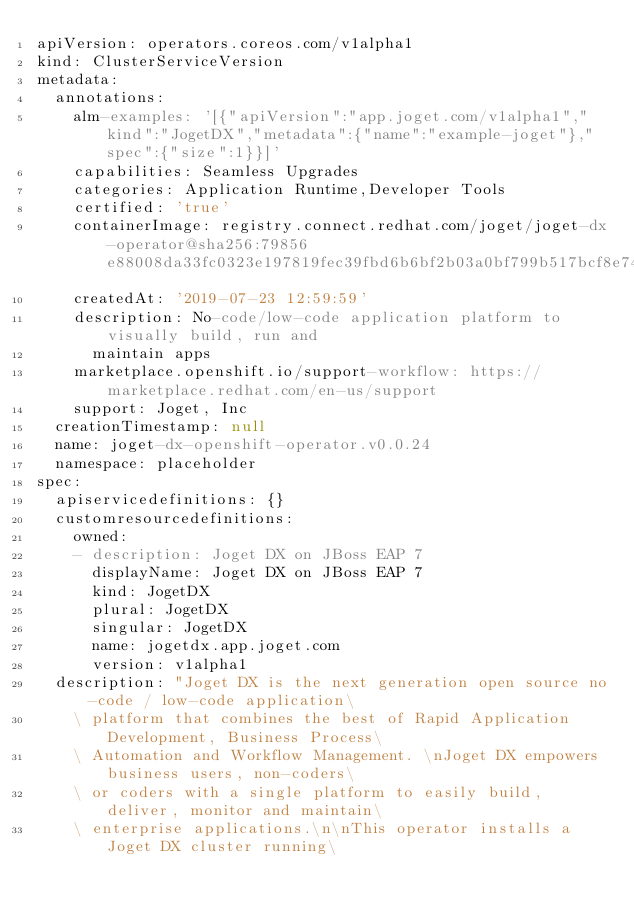<code> <loc_0><loc_0><loc_500><loc_500><_YAML_>apiVersion: operators.coreos.com/v1alpha1
kind: ClusterServiceVersion
metadata:
  annotations:
    alm-examples: '[{"apiVersion":"app.joget.com/v1alpha1","kind":"JogetDX","metadata":{"name":"example-joget"},"spec":{"size":1}}]'
    capabilities: Seamless Upgrades
    categories: Application Runtime,Developer Tools
    certified: 'true'
    containerImage: registry.connect.redhat.com/joget/joget-dx-operator@sha256:79856e88008da33fc0323e197819fec39fbd6b6bf2b03a0bf799b517bcf8e749
    createdAt: '2019-07-23 12:59:59'
    description: No-code/low-code application platform to visually build, run and
      maintain apps
    marketplace.openshift.io/support-workflow: https://marketplace.redhat.com/en-us/support
    support: Joget, Inc
  creationTimestamp: null
  name: joget-dx-openshift-operator.v0.0.24
  namespace: placeholder
spec:
  apiservicedefinitions: {}
  customresourcedefinitions:
    owned:
    - description: Joget DX on JBoss EAP 7
      displayName: Joget DX on JBoss EAP 7
      kind: JogetDX
      plural: JogetDX
      singular: JogetDX
      name: jogetdx.app.joget.com
      version: v1alpha1
  description: "Joget DX is the next generation open source no-code / low-code application\
    \ platform that combines the best of Rapid Application Development, Business Process\
    \ Automation and Workflow Management. \nJoget DX empowers business users, non-coders\
    \ or coders with a single platform to easily build, deliver, monitor and maintain\
    \ enterprise applications.\n\nThis operator installs a Joget DX cluster running\</code> 